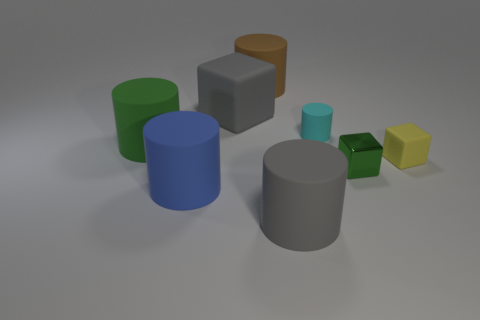Is there any other thing that has the same material as the small green cube?
Offer a terse response. No. Are there fewer green things that are on the left side of the large green rubber object than yellow matte blocks?
Provide a short and direct response. Yes. Are there more big objects that are left of the big brown cylinder than brown matte cylinders that are in front of the small cyan matte cylinder?
Provide a short and direct response. Yes. Is there anything else that has the same color as the metallic thing?
Ensure brevity in your answer.  Yes. What material is the tiny cube right of the small green thing?
Keep it short and to the point. Rubber. Is the gray block the same size as the cyan cylinder?
Ensure brevity in your answer.  No. What number of other objects are there of the same size as the yellow matte object?
Give a very brief answer. 2. The green object to the right of the small thing that is behind the big green cylinder on the left side of the yellow rubber thing is what shape?
Offer a very short reply. Cube. What number of things are things in front of the tiny metallic cube or big cylinders that are right of the green cylinder?
Your response must be concise. 3. There is a gray matte object behind the tiny cyan object that is left of the small yellow matte block; how big is it?
Offer a very short reply. Large. 